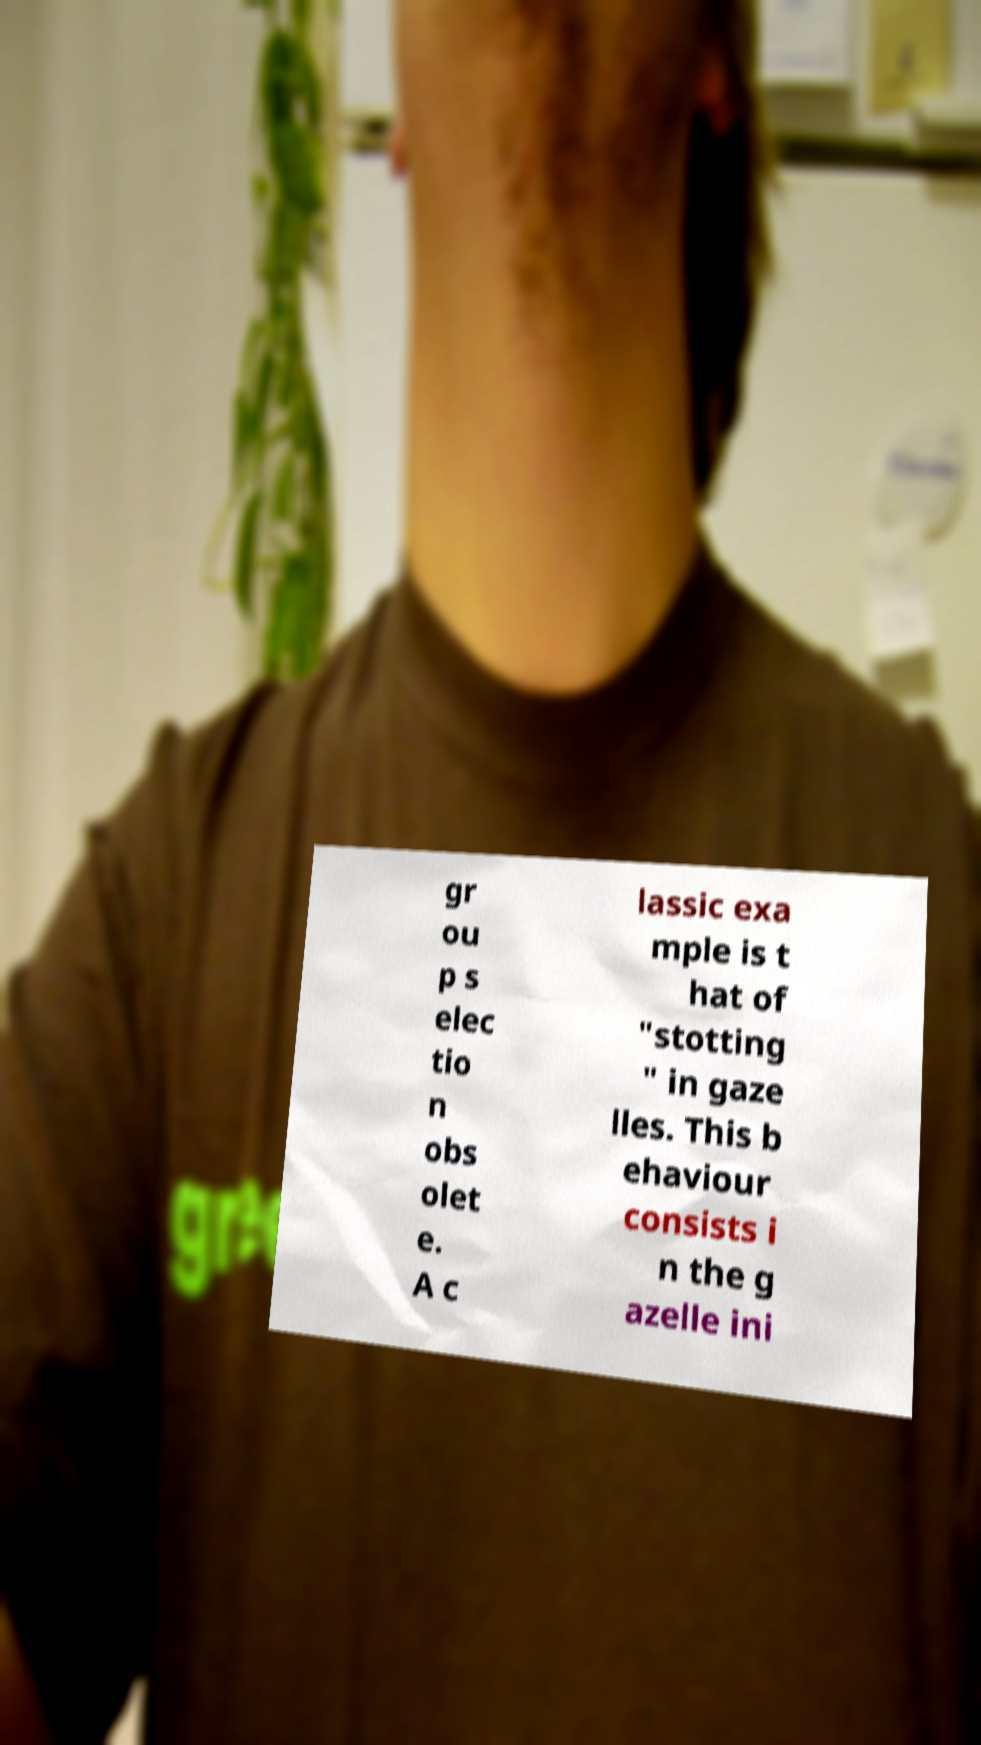Please read and relay the text visible in this image. What does it say? gr ou p s elec tio n obs olet e. A c lassic exa mple is t hat of "stotting " in gaze lles. This b ehaviour consists i n the g azelle ini 